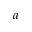Convert formula to latex. <formula><loc_0><loc_0><loc_500><loc_500>a</formula> 